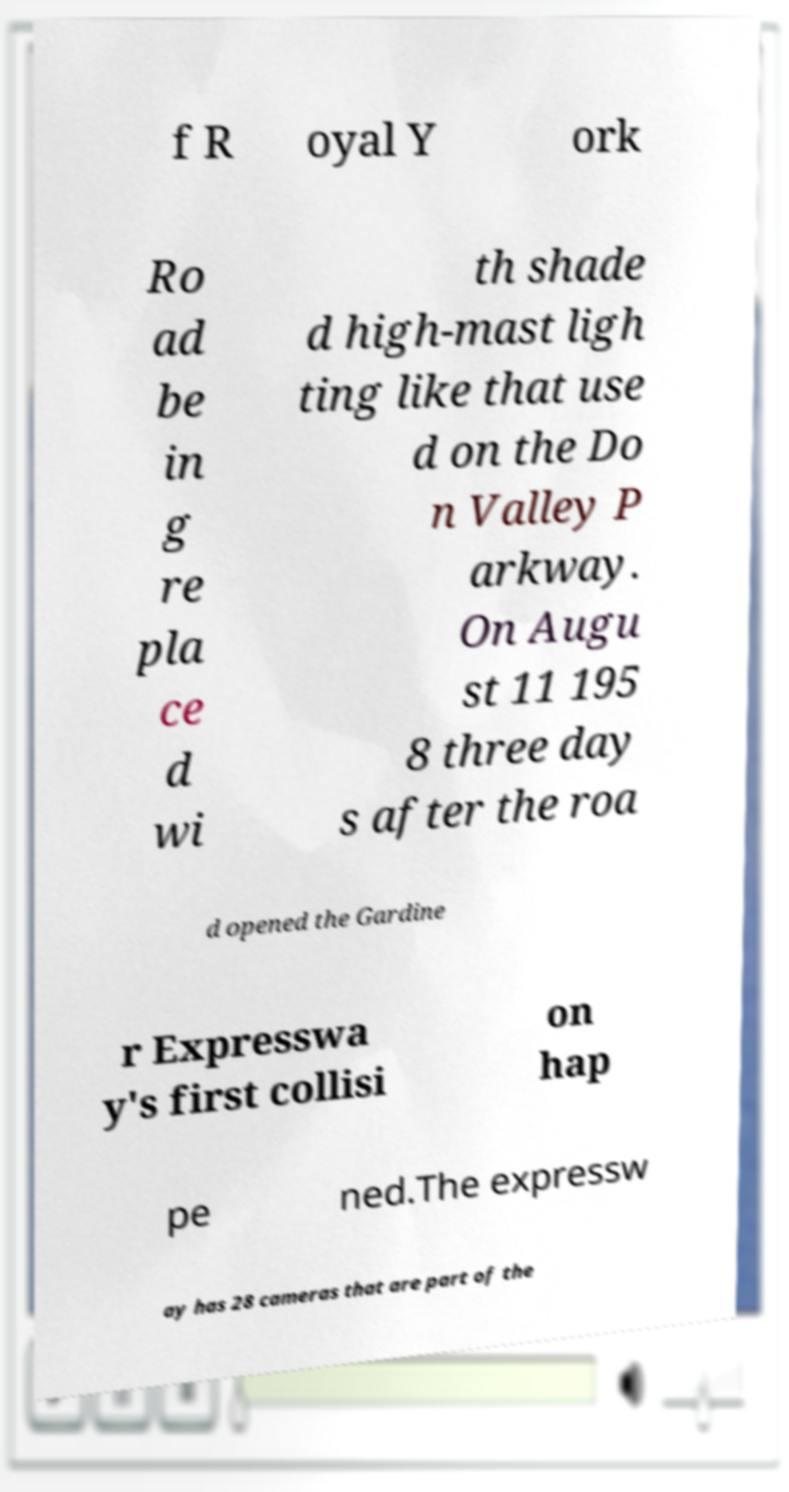Please read and relay the text visible in this image. What does it say? f R oyal Y ork Ro ad be in g re pla ce d wi th shade d high-mast ligh ting like that use d on the Do n Valley P arkway. On Augu st 11 195 8 three day s after the roa d opened the Gardine r Expresswa y's first collisi on hap pe ned.The expressw ay has 28 cameras that are part of the 